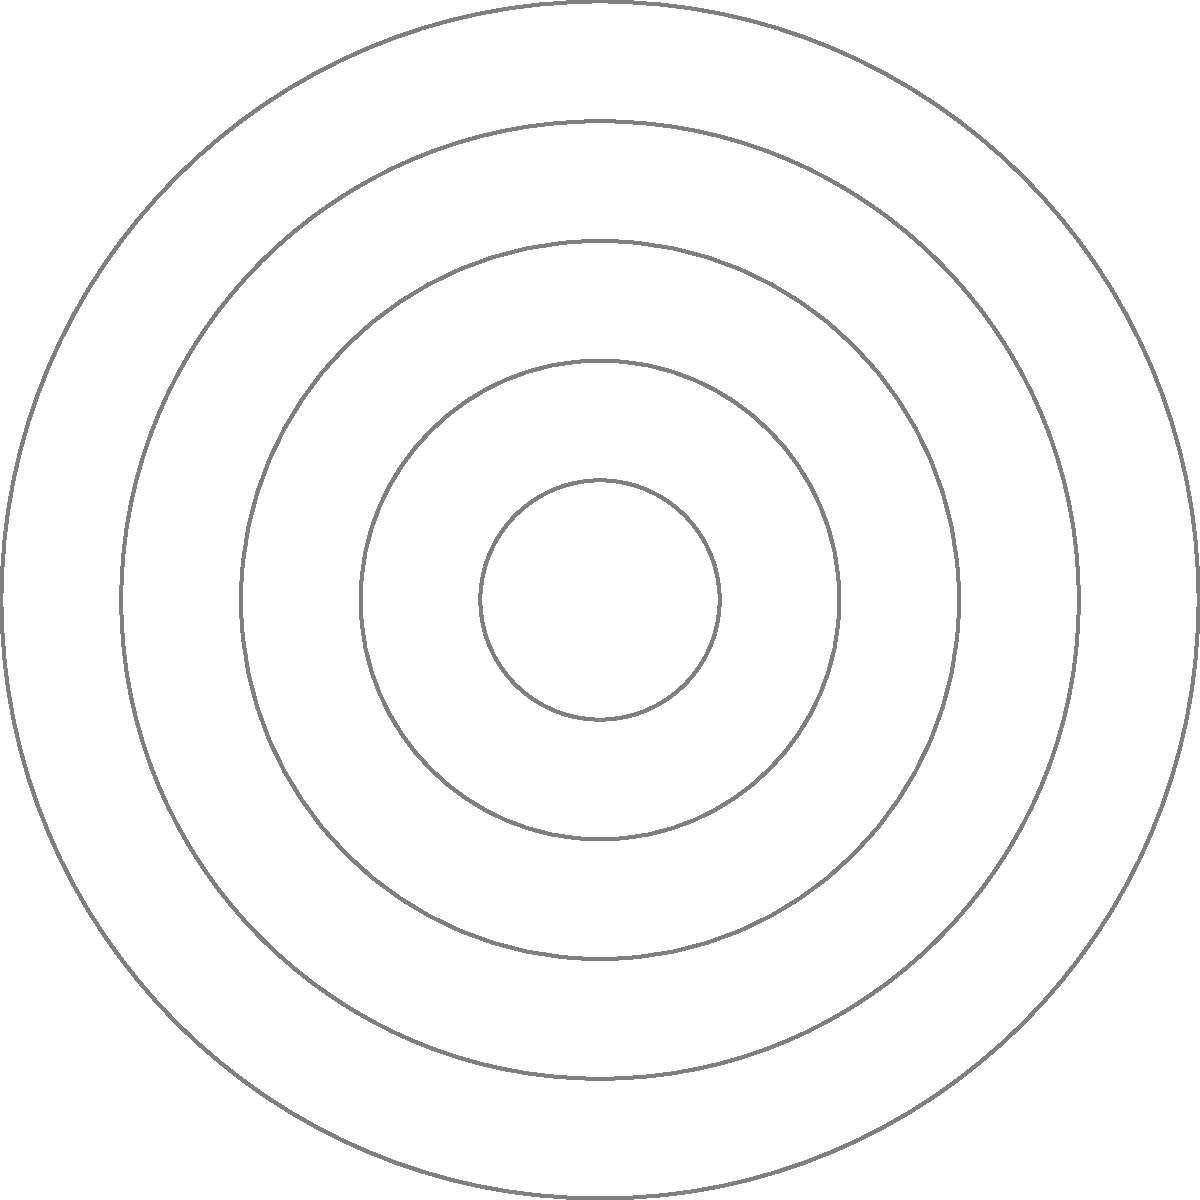As a small business owner in Delta, Colorado, you're plotting the locations of local businesses on a polar grid to visualize market coverage. A competing business is located at the point $(r, \theta) = (5, 60°)$ on the grid. What are the Cartesian coordinates $(x, y)$ of this business, rounded to two decimal places? To convert polar coordinates $(r, \theta)$ to Cartesian coordinates $(x, y)$, we use these formulas:

1) $x = r \cos(\theta)$
2) $y = r \sin(\theta)$

Given:
$r = 5$
$\theta = 60°$

Step 1: Calculate x
$x = 5 \cos(60°)$
$x = 5 \cdot 0.5 = 2.5$

Step 2: Calculate y
$y = 5 \sin(60°)$
$y = 5 \cdot \frac{\sqrt{3}}{2} \approx 4.33$

Step 3: Round to two decimal places
$x \approx 2.50$
$y \approx 4.33$

Therefore, the Cartesian coordinates are $(2.50, 4.33)$.
Answer: $(2.50, 4.33)$ 